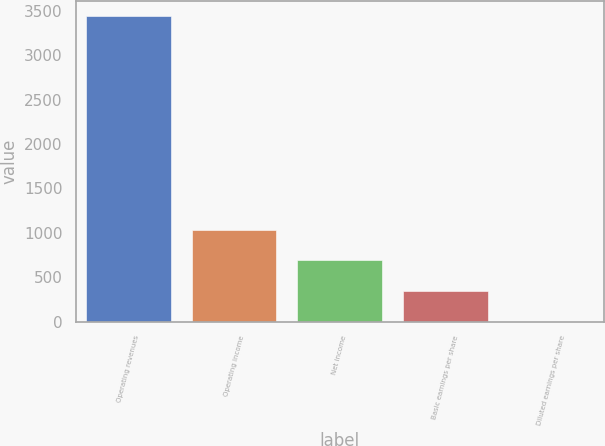Convert chart to OTSL. <chart><loc_0><loc_0><loc_500><loc_500><bar_chart><fcel>Operating revenues<fcel>Operating income<fcel>Net income<fcel>Basic earnings per share<fcel>Diluted earnings per share<nl><fcel>3443<fcel>1033.92<fcel>689.77<fcel>345.61<fcel>1.45<nl></chart> 